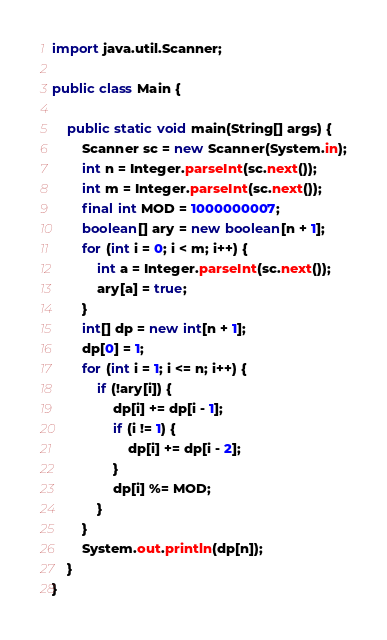Convert code to text. <code><loc_0><loc_0><loc_500><loc_500><_Java_>import java.util.Scanner;

public class Main {

    public static void main(String[] args) {
        Scanner sc = new Scanner(System.in);
        int n = Integer.parseInt(sc.next());
        int m = Integer.parseInt(sc.next());
        final int MOD = 1000000007;
        boolean[] ary = new boolean[n + 1];
        for (int i = 0; i < m; i++) {
            int a = Integer.parseInt(sc.next());
            ary[a] = true;
        }
        int[] dp = new int[n + 1];
        dp[0] = 1;
        for (int i = 1; i <= n; i++) {
            if (!ary[i]) {
                dp[i] += dp[i - 1];
                if (i != 1) {
                    dp[i] += dp[i - 2];
                }
                dp[i] %= MOD;
            }
        }
        System.out.println(dp[n]);
    }
}</code> 